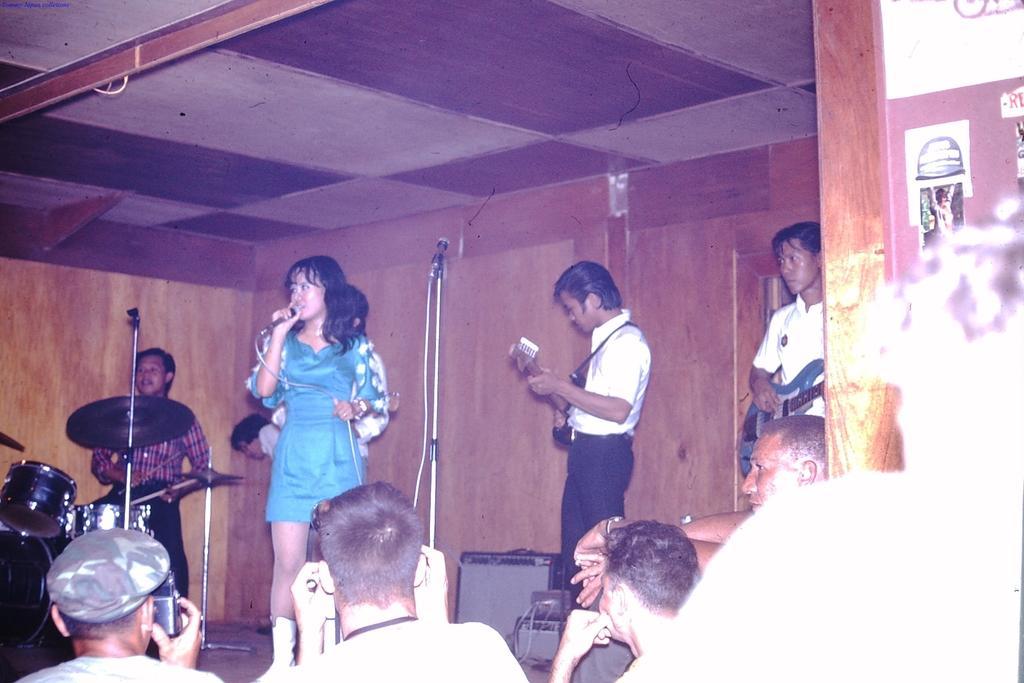Could you give a brief overview of what you see in this image? In this image i can see few people own the stage holding camera in their hands. On the stage i can see few people standing and holding musical instruments in their hands, i can see microphones in front of them in the background i can see the wall and the roof. 